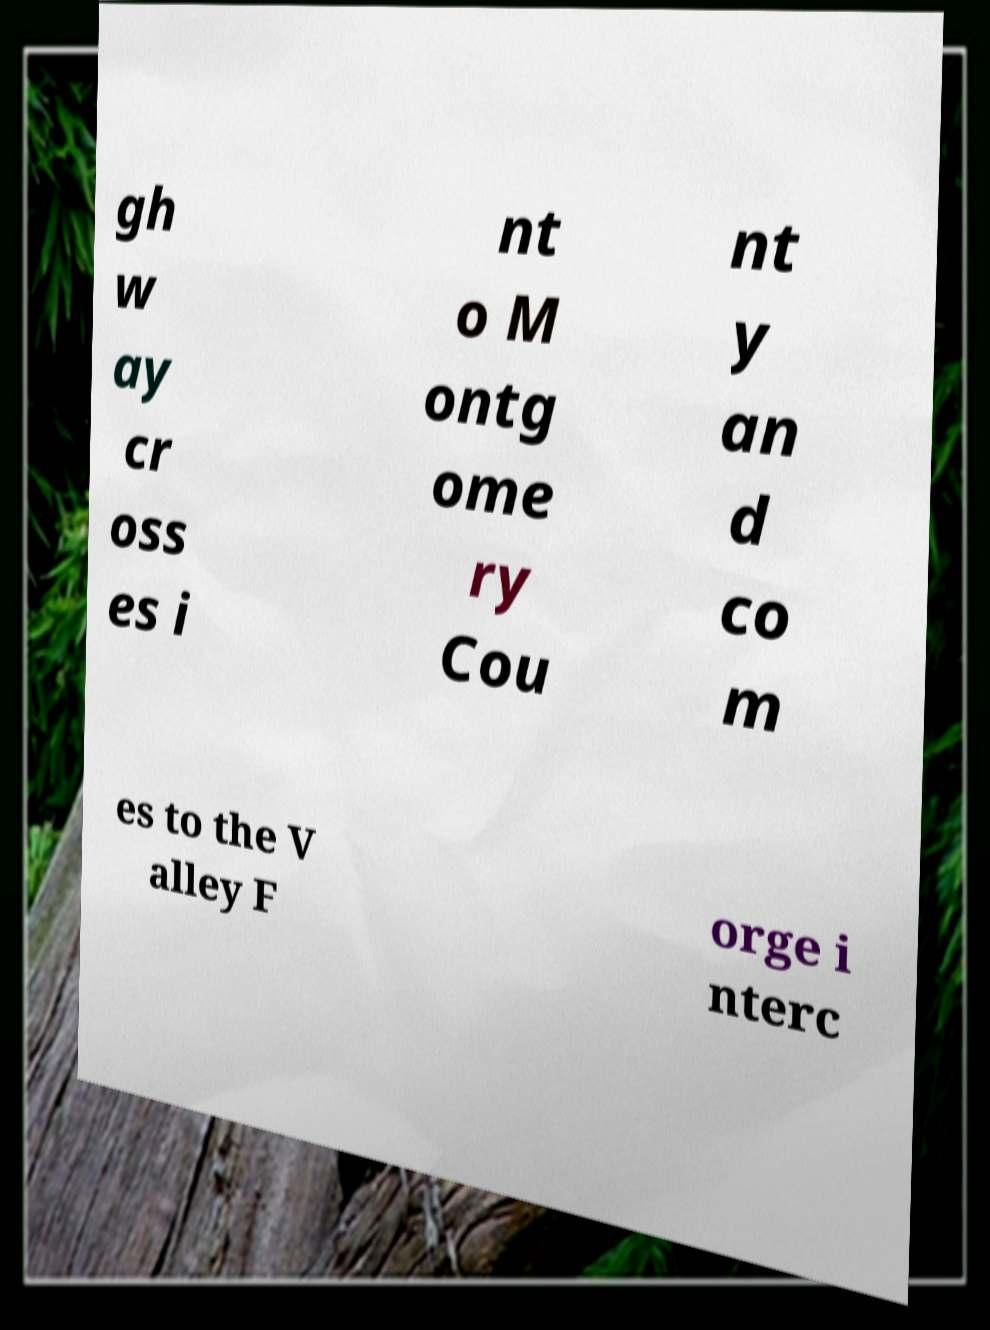Please read and relay the text visible in this image. What does it say? gh w ay cr oss es i nt o M ontg ome ry Cou nt y an d co m es to the V alley F orge i nterc 